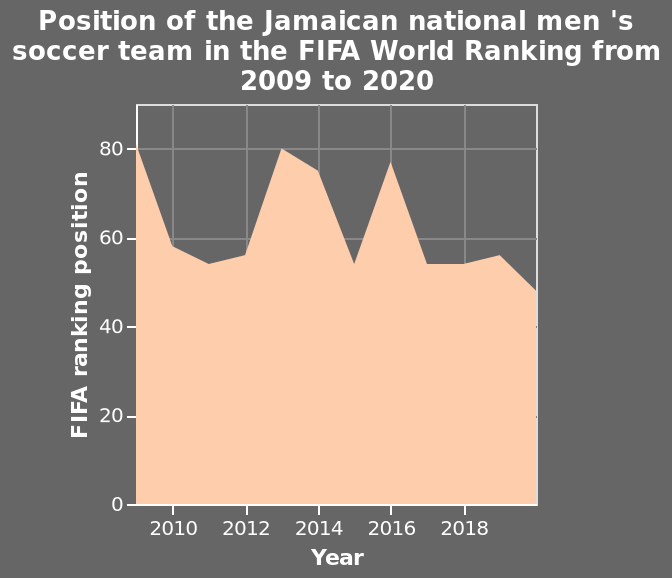<image>
Which year had the highest ranking for the Jamaican men's soccer team between 2009 and 2020? The year 2016 had the highest ranking for the Jamaican men's soccer team between 2009 and 2020. What is shown on the y-axis of the chart? The y-axis of the chart measures the FIFA ranking position, ranging from 0 to 80. Which year had the lowest ranking for the Jamaican men's soccer team between 2009 and 2020? The year 2020 had the lowest ranking for the Jamaican men's soccer team between 2009 and 2020. please describe the details of the chart Position of the Jamaican national men 's soccer team in the FIFA World Ranking from 2009 to 2020 is a area chart. The x-axis shows Year with linear scale with a minimum of 2010 and a maximum of 2018 while the y-axis measures FIFA ranking position with linear scale from 0 to 80. What were the prominent lowest points for the Jamaican men's soccer team's FIFA ranking between 2009 and 2020? The prominent lowest points for the Jamaican men's soccer team's FIFA ranking between 2009 and 2020 were 2011, 2015, and 2020. 